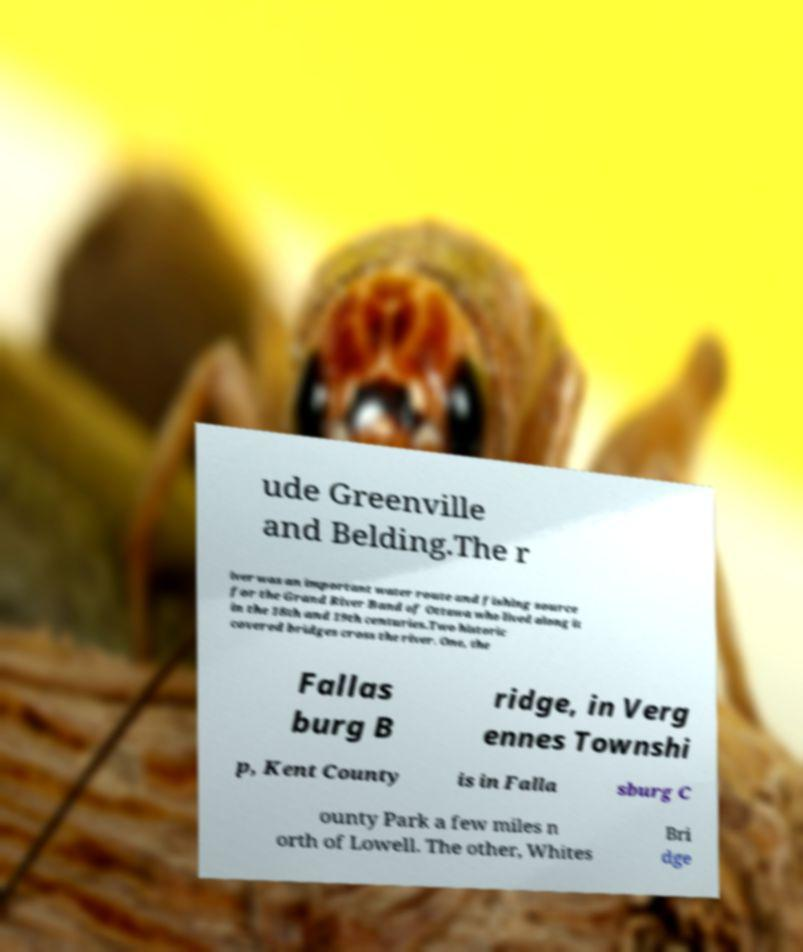Can you accurately transcribe the text from the provided image for me? ude Greenville and Belding.The r iver was an important water route and fishing source for the Grand River Band of Ottawa who lived along it in the 18th and 19th centuries.Two historic covered bridges cross the river. One, the Fallas burg B ridge, in Verg ennes Townshi p, Kent County is in Falla sburg C ounty Park a few miles n orth of Lowell. The other, Whites Bri dge 